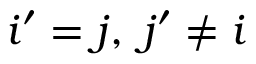Convert formula to latex. <formula><loc_0><loc_0><loc_500><loc_500>i ^ { \prime } = j , \, j ^ { \prime } \neq i</formula> 